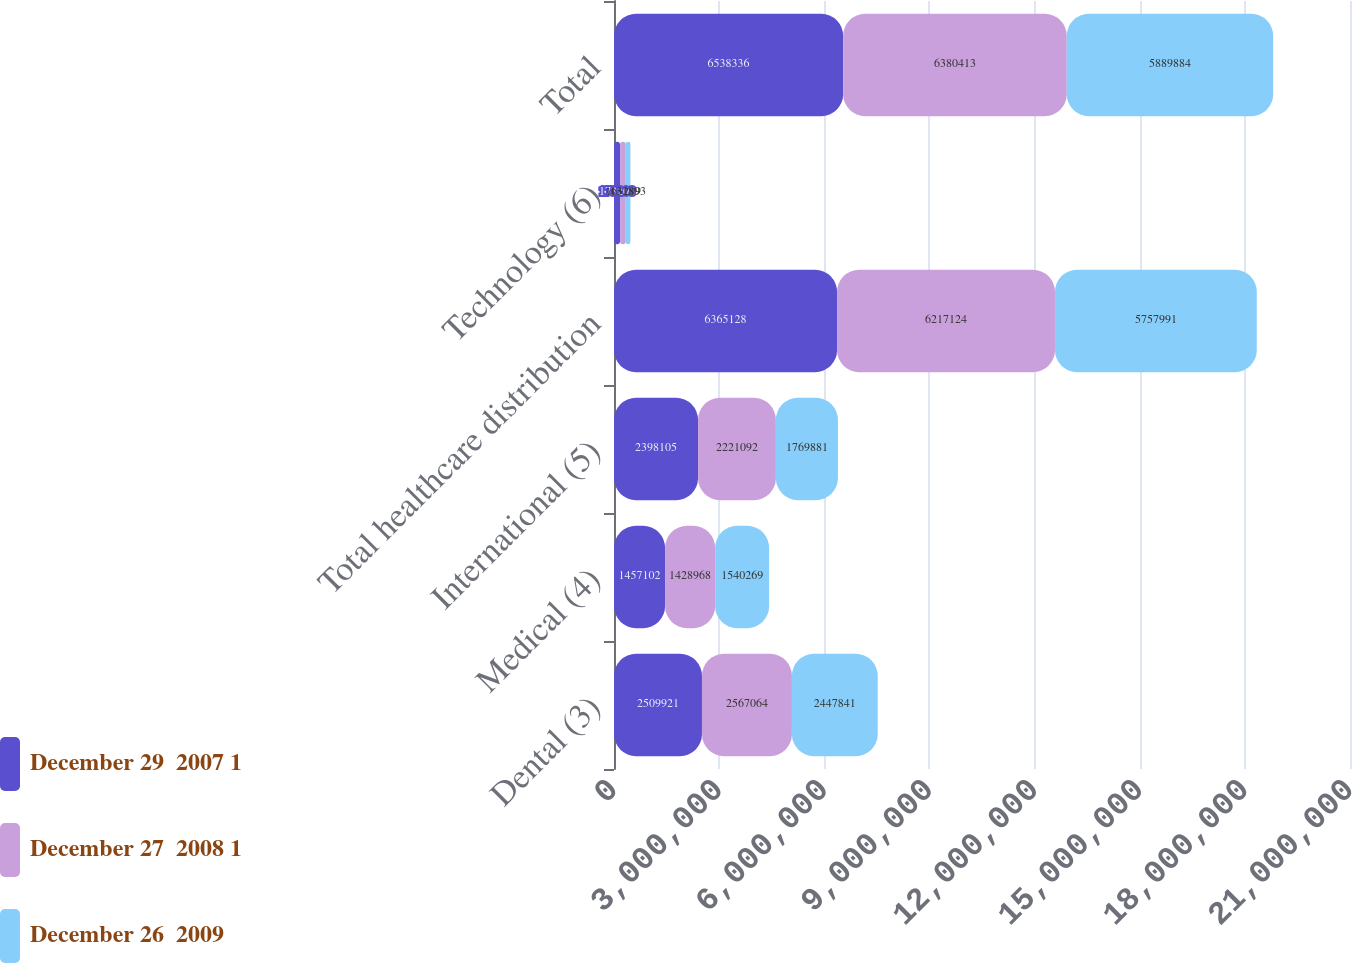Convert chart. <chart><loc_0><loc_0><loc_500><loc_500><stacked_bar_chart><ecel><fcel>Dental (3)<fcel>Medical (4)<fcel>International (5)<fcel>Total healthcare distribution<fcel>Technology (6)<fcel>Total<nl><fcel>December 29  2007 1<fcel>2.50992e+06<fcel>1.4571e+06<fcel>2.3981e+06<fcel>6.36513e+06<fcel>173208<fcel>6.53834e+06<nl><fcel>December 27  2008 1<fcel>2.56706e+06<fcel>1.42897e+06<fcel>2.22109e+06<fcel>6.21712e+06<fcel>163289<fcel>6.38041e+06<nl><fcel>December 26  2009<fcel>2.44784e+06<fcel>1.54027e+06<fcel>1.76988e+06<fcel>5.75799e+06<fcel>131893<fcel>5.88988e+06<nl></chart> 